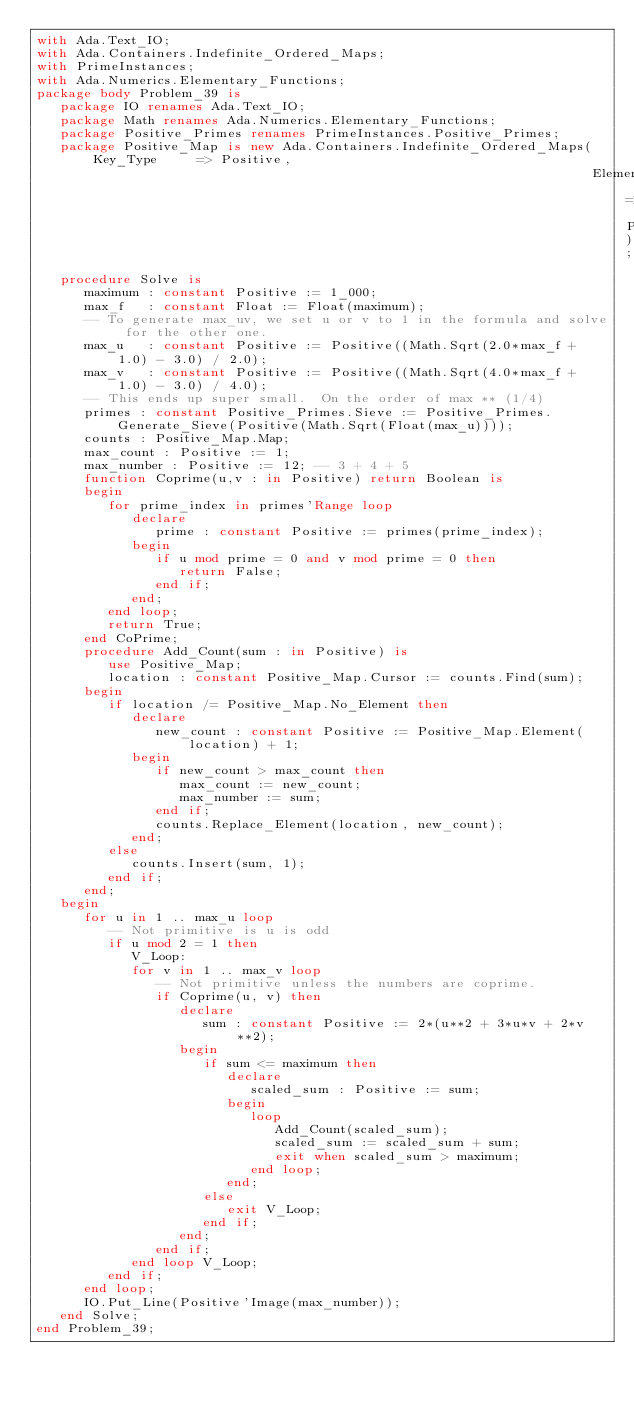<code> <loc_0><loc_0><loc_500><loc_500><_Ada_>with Ada.Text_IO;
with Ada.Containers.Indefinite_Ordered_Maps;
with PrimeInstances;
with Ada.Numerics.Elementary_Functions;
package body Problem_39 is
   package IO renames Ada.Text_IO;
   package Math renames Ada.Numerics.Elementary_Functions;
   package Positive_Primes renames PrimeInstances.Positive_Primes;
   package Positive_Map is new Ada.Containers.Indefinite_Ordered_Maps(Key_Type     => Positive,
                                                                      Element_Type => Positive);
   procedure Solve is
      maximum : constant Positive := 1_000;
      max_f   : constant Float := Float(maximum);
      -- To generate max_uv, we set u or v to 1 in the formula and solve for the other one.
      max_u   : constant Positive := Positive((Math.Sqrt(2.0*max_f + 1.0) - 3.0) / 2.0);
      max_v   : constant Positive := Positive((Math.Sqrt(4.0*max_f + 1.0) - 3.0) / 4.0);
      -- This ends up super small.  On the order of max ** (1/4)
      primes : constant Positive_Primes.Sieve := Positive_Primes.Generate_Sieve(Positive(Math.Sqrt(Float(max_u))));
      counts : Positive_Map.Map;
      max_count : Positive := 1;
      max_number : Positive := 12; -- 3 + 4 + 5
      function Coprime(u,v : in Positive) return Boolean is
      begin
         for prime_index in primes'Range loop
            declare
               prime : constant Positive := primes(prime_index);
            begin
               if u mod prime = 0 and v mod prime = 0 then
                  return False;
               end if;
            end;
         end loop;
         return True;
      end CoPrime;
      procedure Add_Count(sum : in Positive) is
         use Positive_Map;
         location : constant Positive_Map.Cursor := counts.Find(sum);
      begin
         if location /= Positive_Map.No_Element then
            declare
               new_count : constant Positive := Positive_Map.Element(location) + 1;
            begin
               if new_count > max_count then
                  max_count := new_count;
                  max_number := sum;
               end if;
               counts.Replace_Element(location, new_count);
            end;
         else
            counts.Insert(sum, 1);
         end if;
      end;
   begin
      for u in 1 .. max_u loop
         -- Not primitive is u is odd
         if u mod 2 = 1 then
            V_Loop:
            for v in 1 .. max_v loop
               -- Not primitive unless the numbers are coprime.
               if Coprime(u, v) then
                  declare
                     sum : constant Positive := 2*(u**2 + 3*u*v + 2*v**2);
                  begin
                     if sum <= maximum then
                        declare
                           scaled_sum : Positive := sum;
                        begin
                           loop
                              Add_Count(scaled_sum);
                              scaled_sum := scaled_sum + sum;
                              exit when scaled_sum > maximum;
                           end loop;
                        end;
                     else
                        exit V_Loop;
                     end if;
                  end;
               end if;
            end loop V_Loop;
         end if;
      end loop;
      IO.Put_Line(Positive'Image(max_number));
   end Solve;
end Problem_39;
</code> 